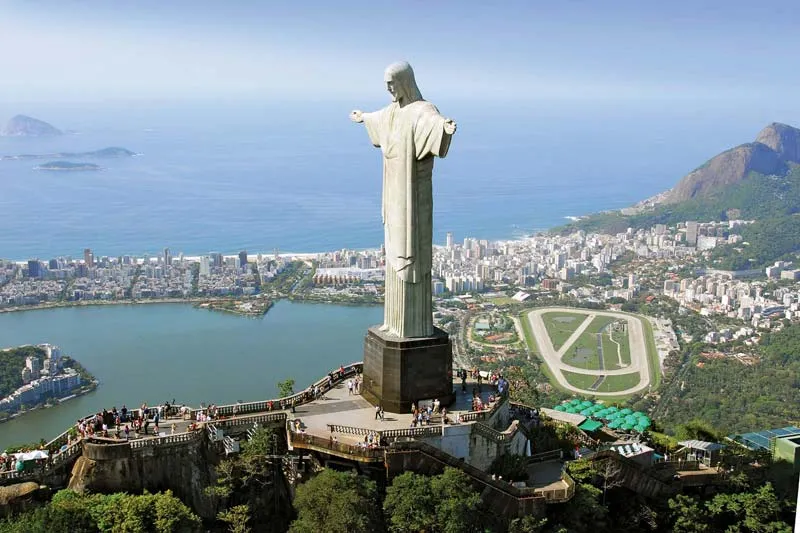Imagine the statue could speak. What would Christ the Redeemer say to the city below? If the Christ the Redeemer statue could speak, it might say, 'My beloved people of Rio and beyond, I extend my arms in a perpetual embrace of peace and love. In times of trial and triumph, I stand as a sentinel of hope, a reminder of enduring faith. Cherish your diverse culture, help each other, and continue to build a world where unity and compassion reign. Look upon each other with kindness, just as I look over this beautiful city.' 